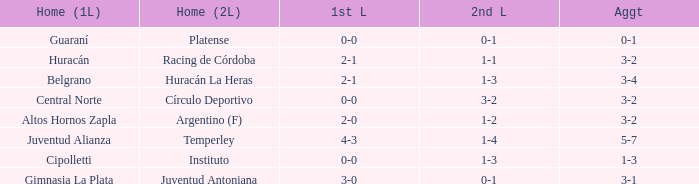Which team participated in the first leg at their home ground with a cumulative score of 3-4? Belgrano. 